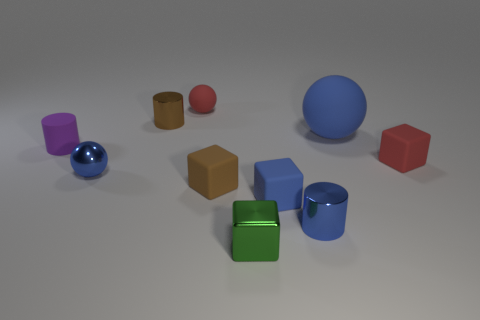Subtract all gray cubes. Subtract all purple spheres. How many cubes are left? 4 Subtract all cylinders. How many objects are left? 7 Add 7 big rubber objects. How many big rubber objects exist? 8 Subtract 0 yellow balls. How many objects are left? 10 Subtract all green spheres. Subtract all big rubber things. How many objects are left? 9 Add 8 purple cylinders. How many purple cylinders are left? 9 